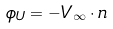<formula> <loc_0><loc_0><loc_500><loc_500>\phi _ { U } = - V _ { \infty } \cdot n</formula> 